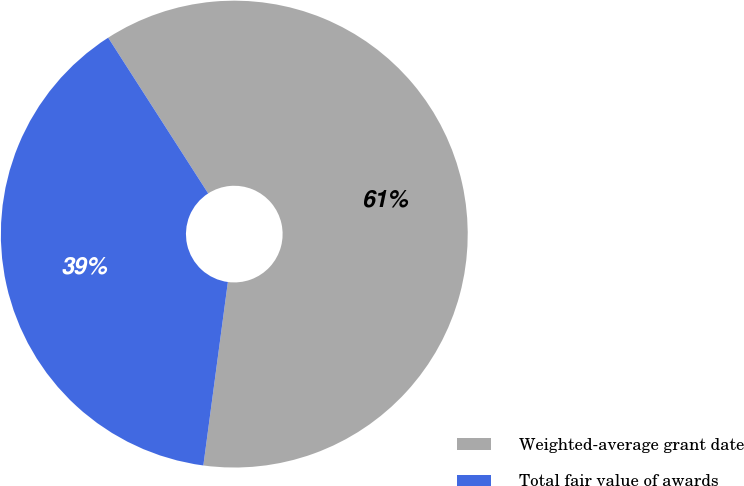Convert chart to OTSL. <chart><loc_0><loc_0><loc_500><loc_500><pie_chart><fcel>Weighted-average grant date<fcel>Total fair value of awards<nl><fcel>61.2%<fcel>38.8%<nl></chart> 